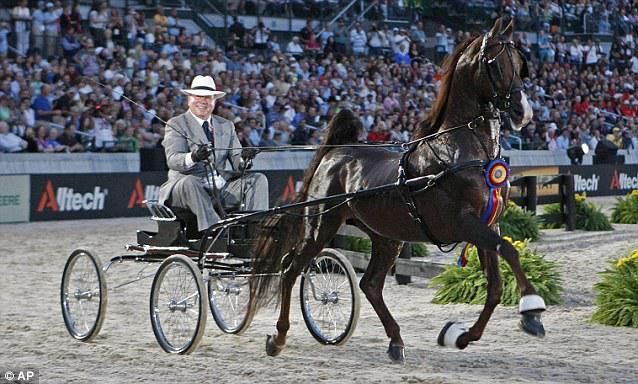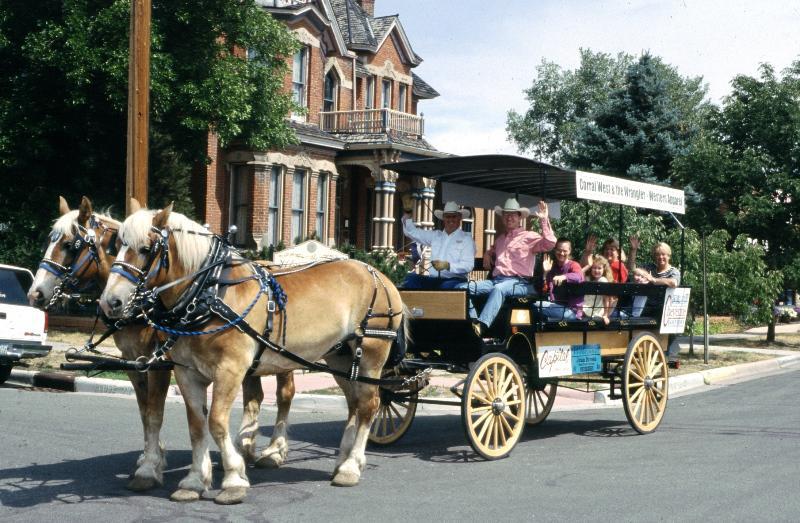The first image is the image on the left, the second image is the image on the right. For the images shown, is this caption "There is one rider in the cart on the left" true? Answer yes or no. Yes. The first image is the image on the left, the second image is the image on the right. Examine the images to the left and right. Is the description "Right image includes a wagon pulled by at least one tan Clydesdale horse" accurate? Answer yes or no. Yes. 